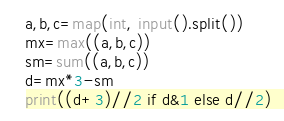<code> <loc_0><loc_0><loc_500><loc_500><_Python_>a,b,c=map(int, input().split())
mx=max((a,b,c))
sm=sum((a,b,c))
d=mx*3-sm
print((d+3)//2 if d&1 else d//2)</code> 